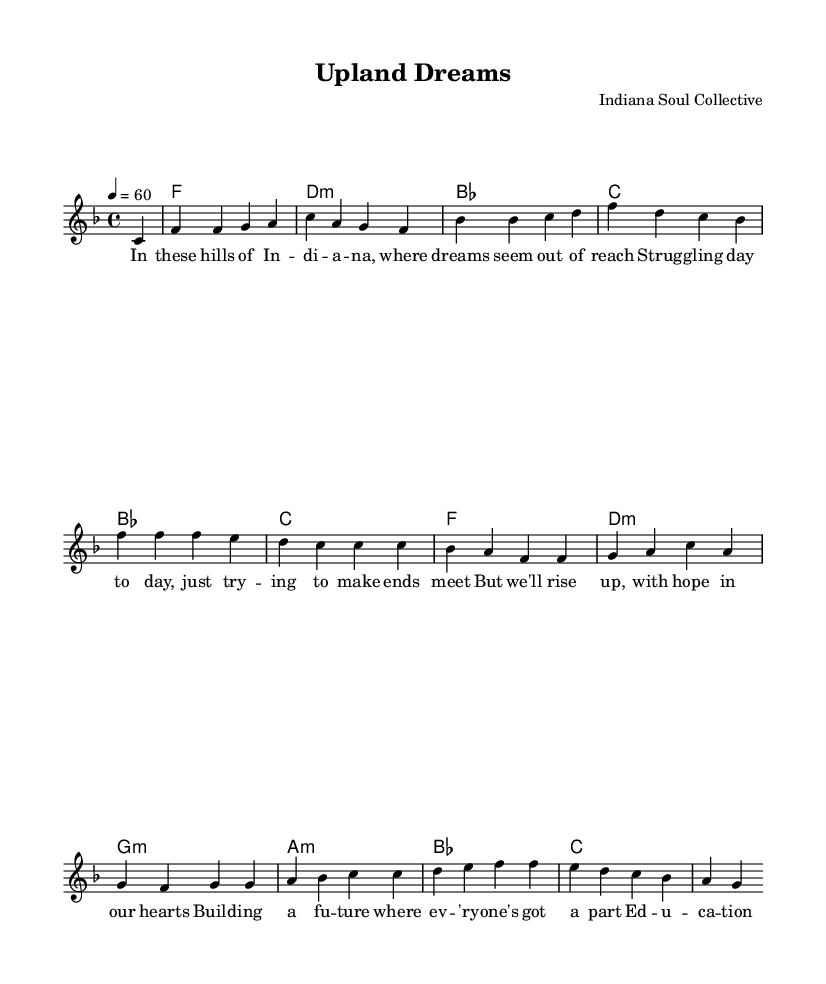What is the key signature of this music? The key signature is F major, indicated by one flat (B flat). This can be identified from the notation at the beginning of the score.
Answer: F major What is the time signature of this music? The time signature is 4/4, which means there are four beats in each measure. This is indicated by the notation at the beginning of the score.
Answer: 4/4 What is the tempo marking of this music? The tempo marking is 60 beats per minute, indicated by the instruction "4 = 60" at the beginning of the score. This tells the player how fast to perform the piece.
Answer: 60 How many measures are in the chorus section? The chorus consists of 2 measures. Counting the bars in the chorus lyrics helps determine how many distinct measures are present.
Answer: 2 Which chord appears first in the harmony? The first chord in the harmony is F major, as listed in the harmonies. It is the first entry in the chord progression sequence.
Answer: F What theme do the lyrics of this ballad primarily address? The lyrics primarily address economic challenges and hope for better opportunities, as evidenced by phrases discussing struggles and the importance of education. This can be inferred from the text in the verses and chorus.
Answer: Economic challenges and hope How does the bridge section connect to the overall message of the piece? The bridge focuses on striving for improvement "from factory floors to classroom doors" which reinforces the theme of pursuing better opportunities. This ties together the message of hope and community strength.
Answer: Connects to hope and improvement 